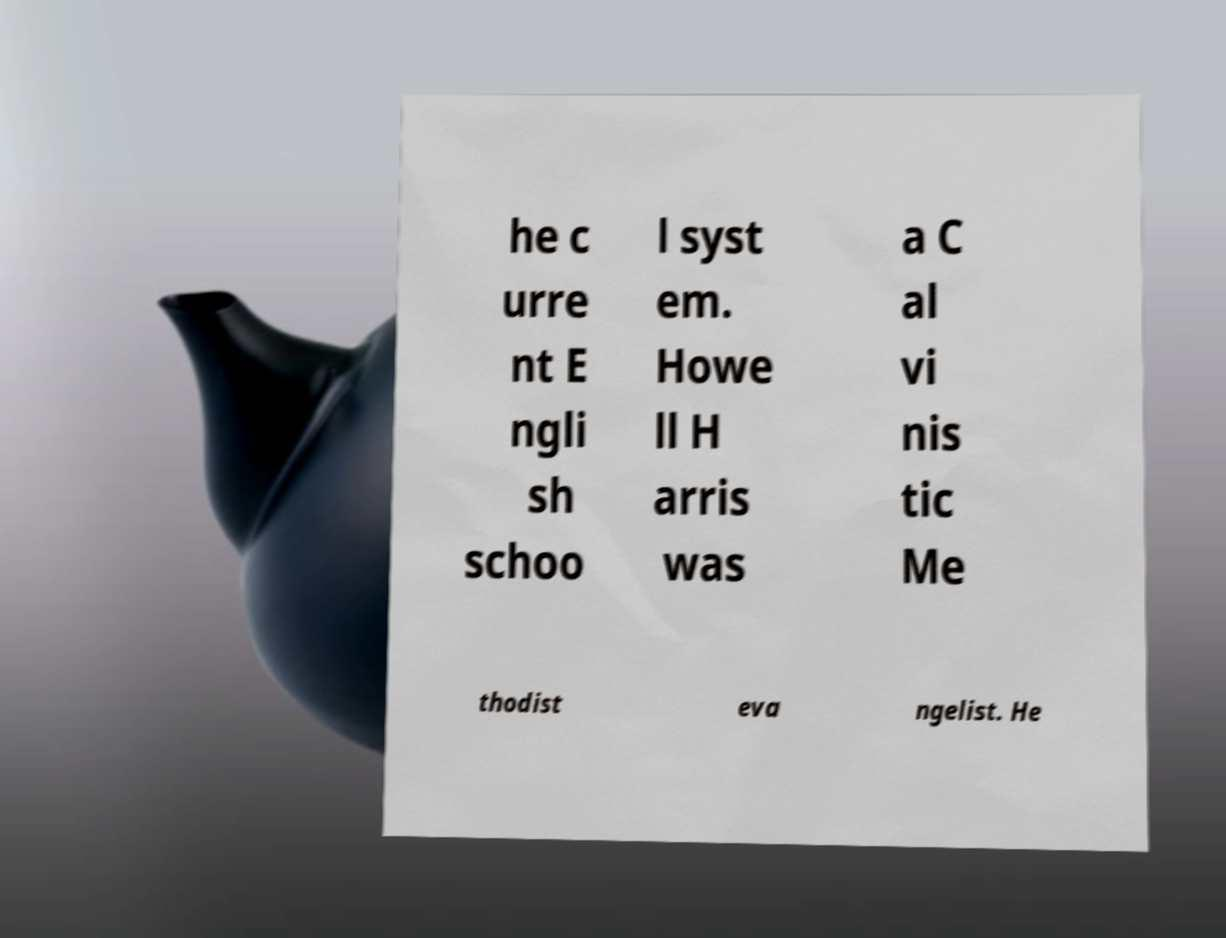Please read and relay the text visible in this image. What does it say? he c urre nt E ngli sh schoo l syst em. Howe ll H arris was a C al vi nis tic Me thodist eva ngelist. He 